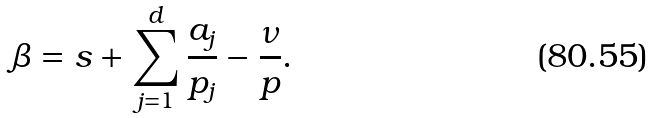<formula> <loc_0><loc_0><loc_500><loc_500>\beta = s + \sum _ { j = 1 } ^ { d } \frac { a _ { j } } { p _ { j } } - \frac { \nu } { p } .</formula> 